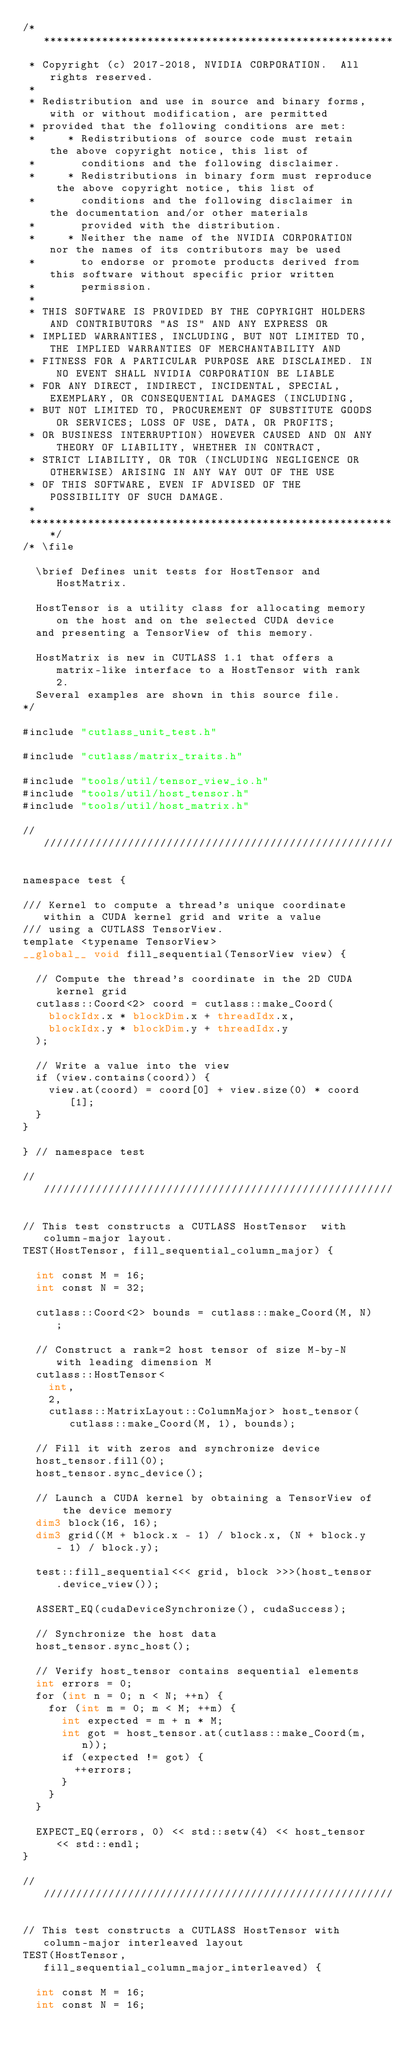Convert code to text. <code><loc_0><loc_0><loc_500><loc_500><_Cuda_>/***************************************************************************************************
 * Copyright (c) 2017-2018, NVIDIA CORPORATION.  All rights reserved.
 *
 * Redistribution and use in source and binary forms, with or without modification, are permitted
 * provided that the following conditions are met:
 *     * Redistributions of source code must retain the above copyright notice, this list of
 *       conditions and the following disclaimer.
 *     * Redistributions in binary form must reproduce the above copyright notice, this list of
 *       conditions and the following disclaimer in the documentation and/or other materials
 *       provided with the distribution.
 *     * Neither the name of the NVIDIA CORPORATION nor the names of its contributors may be used
 *       to endorse or promote products derived from this software without specific prior written
 *       permission.
 *
 * THIS SOFTWARE IS PROVIDED BY THE COPYRIGHT HOLDERS AND CONTRIBUTORS "AS IS" AND ANY EXPRESS OR
 * IMPLIED WARRANTIES, INCLUDING, BUT NOT LIMITED TO, THE IMPLIED WARRANTIES OF MERCHANTABILITY AND
 * FITNESS FOR A PARTICULAR PURPOSE ARE DISCLAIMED. IN NO EVENT SHALL NVIDIA CORPORATION BE LIABLE
 * FOR ANY DIRECT, INDIRECT, INCIDENTAL, SPECIAL, EXEMPLARY, OR CONSEQUENTIAL DAMAGES (INCLUDING,
 * BUT NOT LIMITED TO, PROCUREMENT OF SUBSTITUTE GOODS OR SERVICES; LOSS OF USE, DATA, OR PROFITS;
 * OR BUSINESS INTERRUPTION) HOWEVER CAUSED AND ON ANY THEORY OF LIABILITY, WHETHER IN CONTRACT,
 * STRICT LIABILITY, OR TOR (INCLUDING NEGLIGENCE OR OTHERWISE) ARISING IN ANY WAY OUT OF THE USE
 * OF THIS SOFTWARE, EVEN IF ADVISED OF THE POSSIBILITY OF SUCH DAMAGE.
 *
 **************************************************************************************************/
/* \file

  \brief Defines unit tests for HostTensor and HostMatrix.

  HostTensor is a utility class for allocating memory on the host and on the selected CUDA device
  and presenting a TensorView of this memory.

  HostMatrix is new in CUTLASS 1.1 that offers a matrix-like interface to a HostTensor with rank 2.
  Several examples are shown in this source file.
*/

#include "cutlass_unit_test.h"

#include "cutlass/matrix_traits.h"

#include "tools/util/tensor_view_io.h"
#include "tools/util/host_tensor.h"
#include "tools/util/host_matrix.h"

////////////////////////////////////////////////////////////////////////////////////////////////////

namespace test {

/// Kernel to compute a thread's unique coordinate within a CUDA kernel grid and write a value
/// using a CUTLASS TensorView.
template <typename TensorView>
__global__ void fill_sequential(TensorView view) {

  // Compute the thread's coordinate in the 2D CUDA kernel grid
  cutlass::Coord<2> coord = cutlass::make_Coord(
    blockIdx.x * blockDim.x + threadIdx.x,
    blockIdx.y * blockDim.y + threadIdx.y
  );

  // Write a value into the view
  if (view.contains(coord)) {
    view.at(coord) = coord[0] + view.size(0) * coord[1];
  }
}

} // namespace test

////////////////////////////////////////////////////////////////////////////////////////////////////

// This test constructs a CUTLASS HostTensor  with column-major layout.
TEST(HostTensor, fill_sequential_column_major) {

  int const M = 16;
  int const N = 32;

  cutlass::Coord<2> bounds = cutlass::make_Coord(M, N);

  // Construct a rank=2 host tensor of size M-by-N with leading dimension M
  cutlass::HostTensor<
    int,
    2,
    cutlass::MatrixLayout::ColumnMajor> host_tensor(cutlass::make_Coord(M, 1), bounds);

  // Fill it with zeros and synchronize device
  host_tensor.fill(0);
  host_tensor.sync_device();

  // Launch a CUDA kernel by obtaining a TensorView of the device memory
  dim3 block(16, 16);
  dim3 grid((M + block.x - 1) / block.x, (N + block.y - 1) / block.y);

  test::fill_sequential<<< grid, block >>>(host_tensor.device_view());

  ASSERT_EQ(cudaDeviceSynchronize(), cudaSuccess);

  // Synchronize the host data
  host_tensor.sync_host();

  // Verify host_tensor contains sequential elements
  int errors = 0;
  for (int n = 0; n < N; ++n) {
    for (int m = 0; m < M; ++m) {
      int expected = m + n * M;
      int got = host_tensor.at(cutlass::make_Coord(m, n));
      if (expected != got) {
        ++errors;
      }
    }
  }

  EXPECT_EQ(errors, 0) << std::setw(4) << host_tensor << std::endl;
}

////////////////////////////////////////////////////////////////////////////////////////////////////

// This test constructs a CUTLASS HostTensor with column-major interleaved layout
TEST(HostTensor, fill_sequential_column_major_interleaved) {

  int const M = 16;
  int const N = 16;</code> 